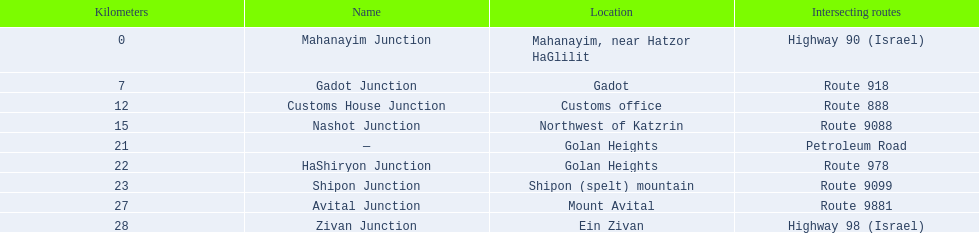How many kilometers away is shipon junction? 23. How many kilometers away is avital junction? 27. Which one is closer to nashot junction? Shipon Junction. 